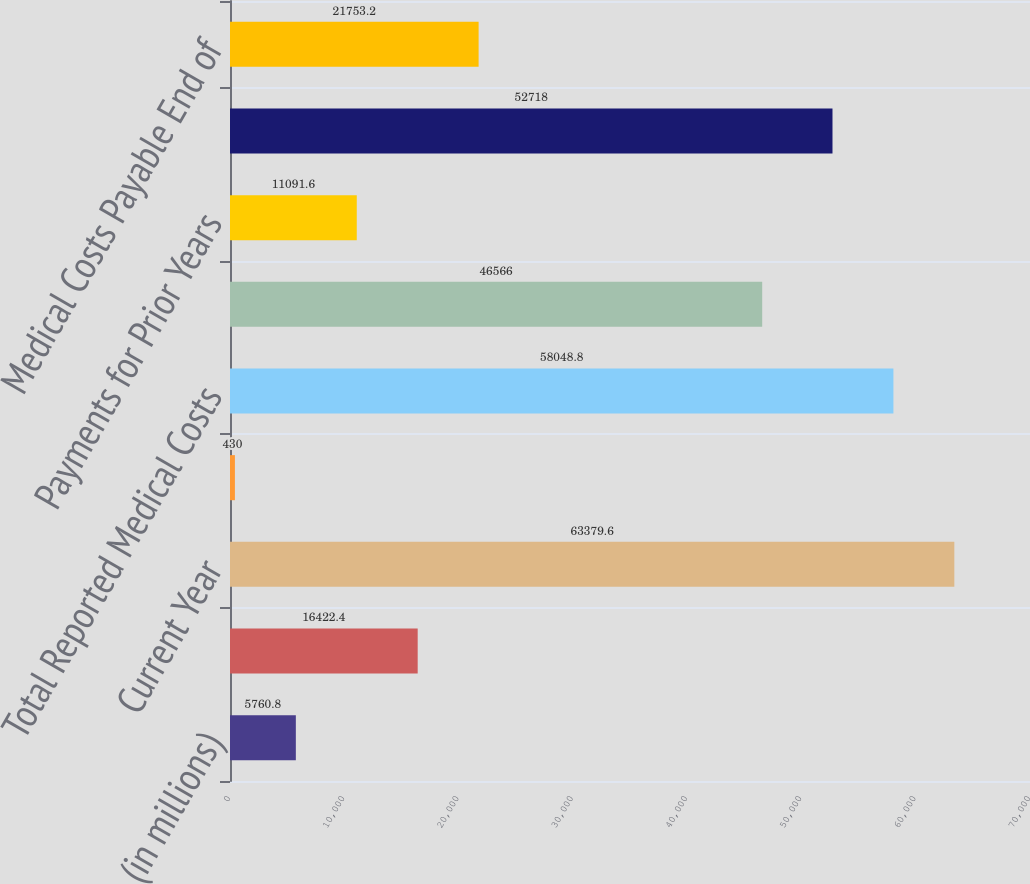Convert chart to OTSL. <chart><loc_0><loc_0><loc_500><loc_500><bar_chart><fcel>(in millions)<fcel>Medical Costs Payable<fcel>Current Year<fcel>Prior Years<fcel>Total Reported Medical Costs<fcel>Payments for Current Year<fcel>Payments for Prior Years<fcel>Total Claim Payments<fcel>Medical Costs Payable End of<nl><fcel>5760.8<fcel>16422.4<fcel>63379.6<fcel>430<fcel>58048.8<fcel>46566<fcel>11091.6<fcel>52718<fcel>21753.2<nl></chart> 